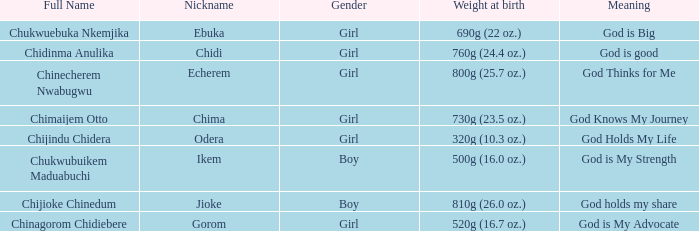0 oz.) at birth? Jioke. 